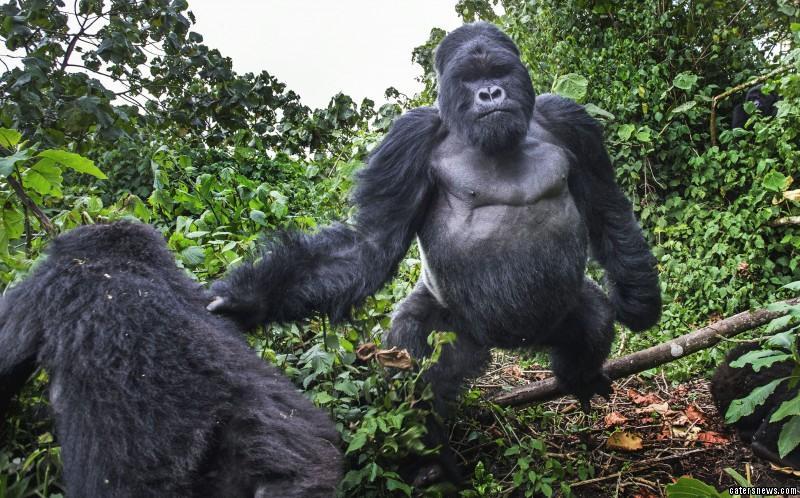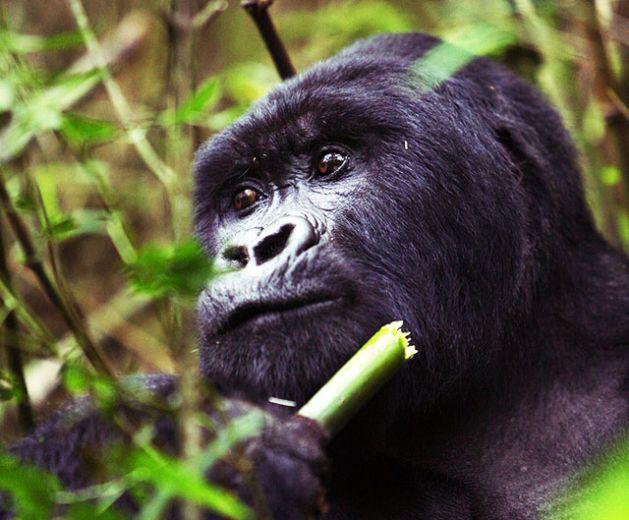The first image is the image on the left, the second image is the image on the right. Evaluate the accuracy of this statement regarding the images: "One image shows a gorilla holding some type of stalk by its face, and the other image features an adult gorilla moving toward the camera.". Is it true? Answer yes or no. Yes. The first image is the image on the left, the second image is the image on the right. For the images shown, is this caption "In each image there is a single gorilla and it is eating." true? Answer yes or no. No. 